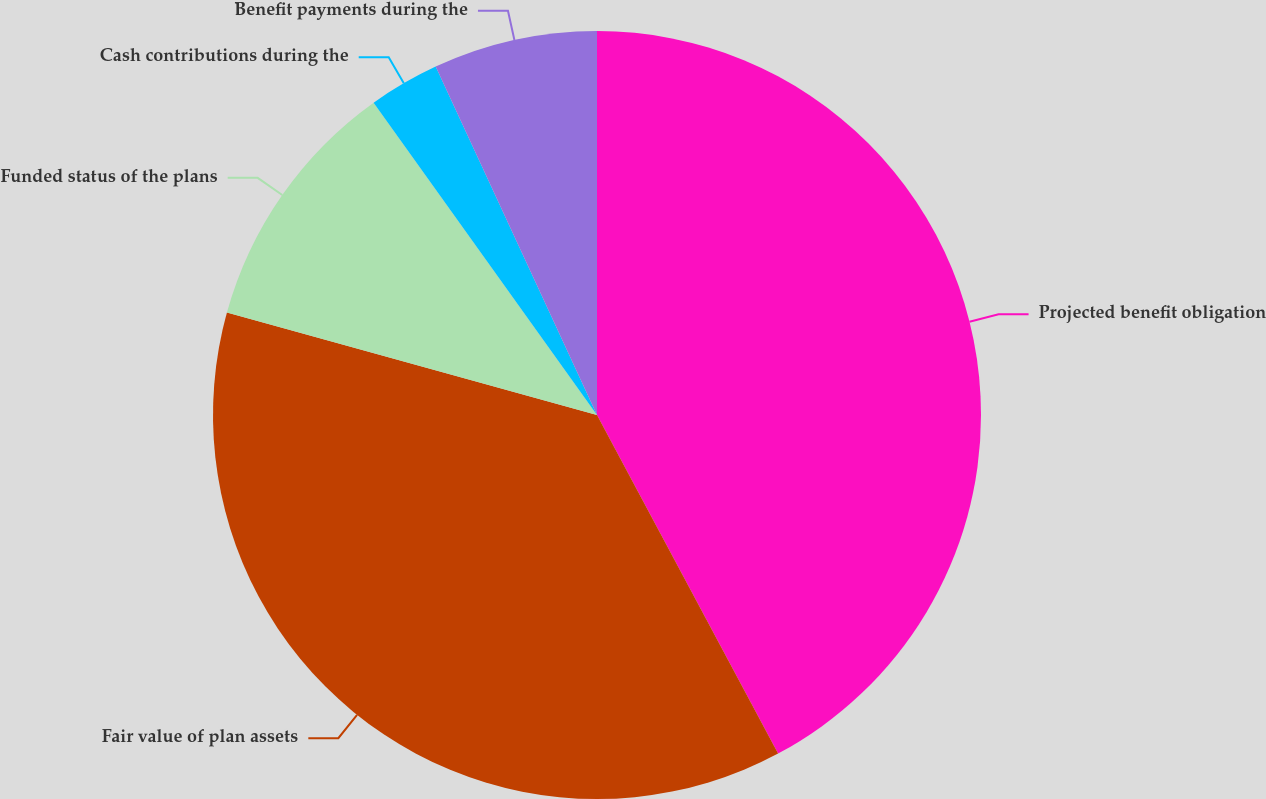<chart> <loc_0><loc_0><loc_500><loc_500><pie_chart><fcel>Projected benefit obligation<fcel>Fair value of plan assets<fcel>Funded status of the plans<fcel>Cash contributions during the<fcel>Benefit payments during the<nl><fcel>42.18%<fcel>37.11%<fcel>10.82%<fcel>2.98%<fcel>6.9%<nl></chart> 